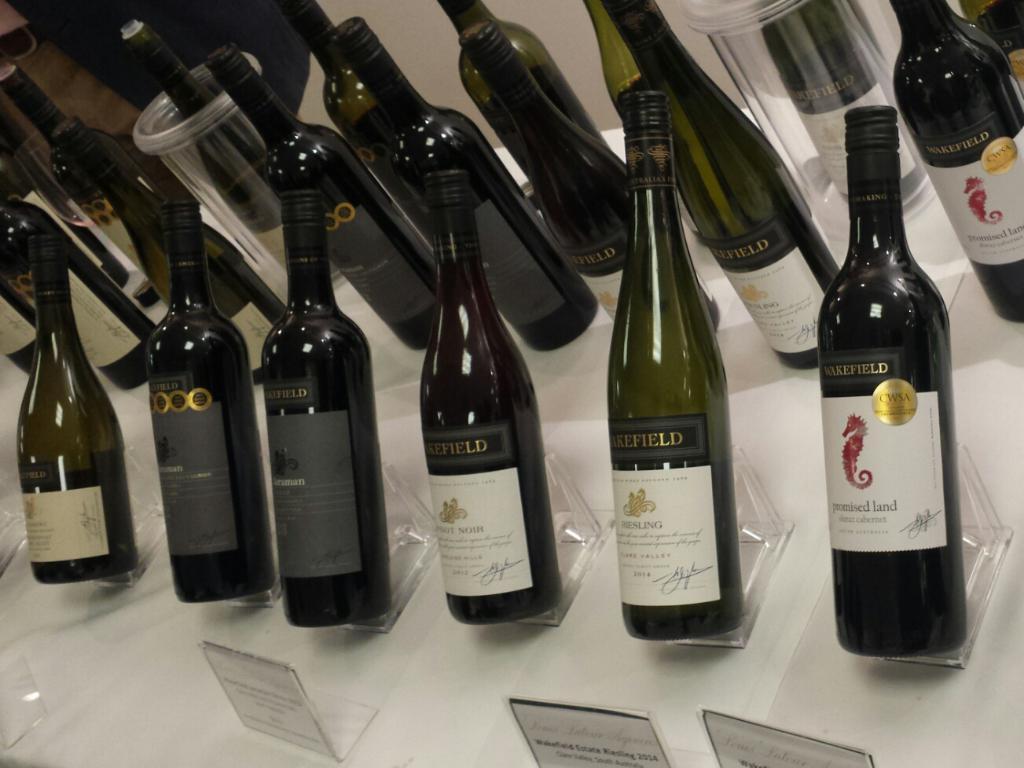Can you describe this image briefly? In a picture there are so many bottles placed on the table with some name plates behind them and in front of them and at the right corner of the picture there is one glass. 